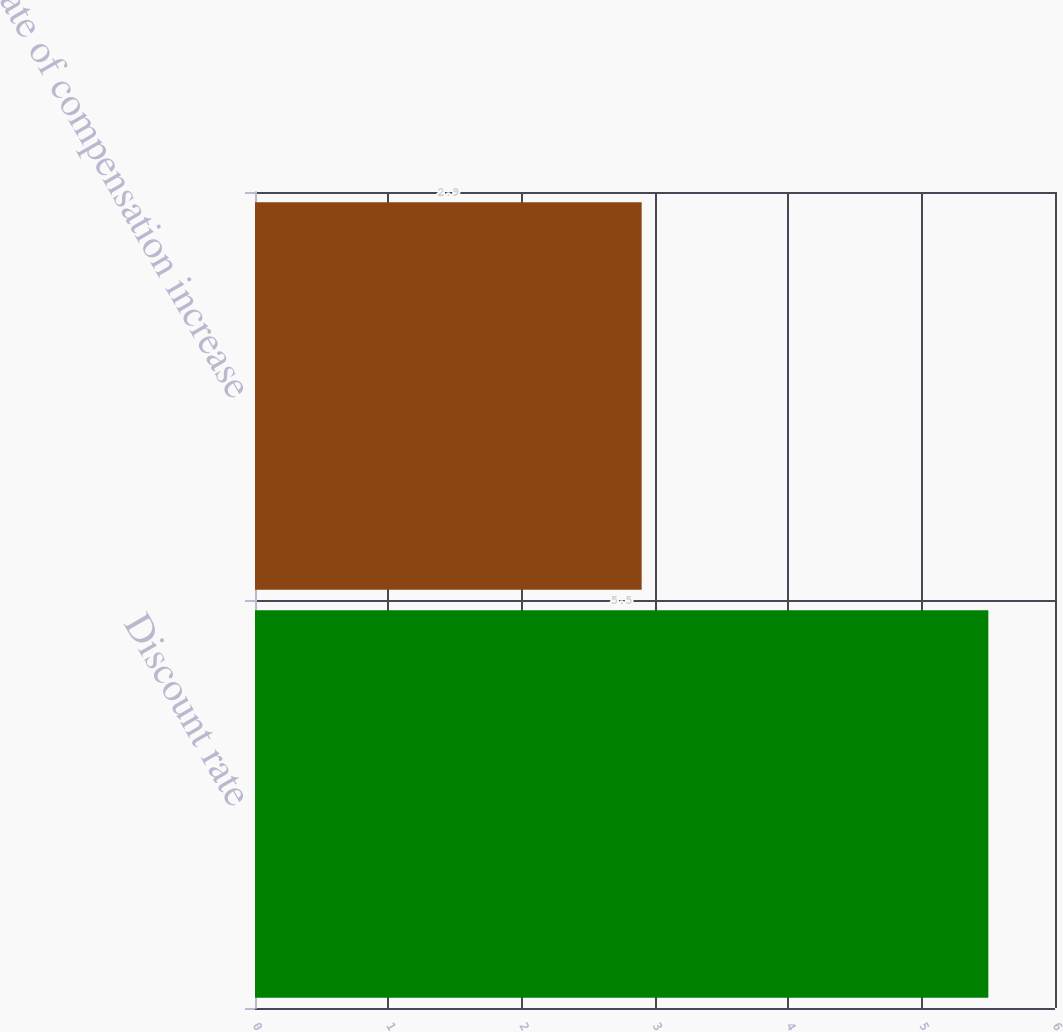<chart> <loc_0><loc_0><loc_500><loc_500><bar_chart><fcel>Discount rate<fcel>Rate of compensation increase<nl><fcel>5.5<fcel>2.9<nl></chart> 